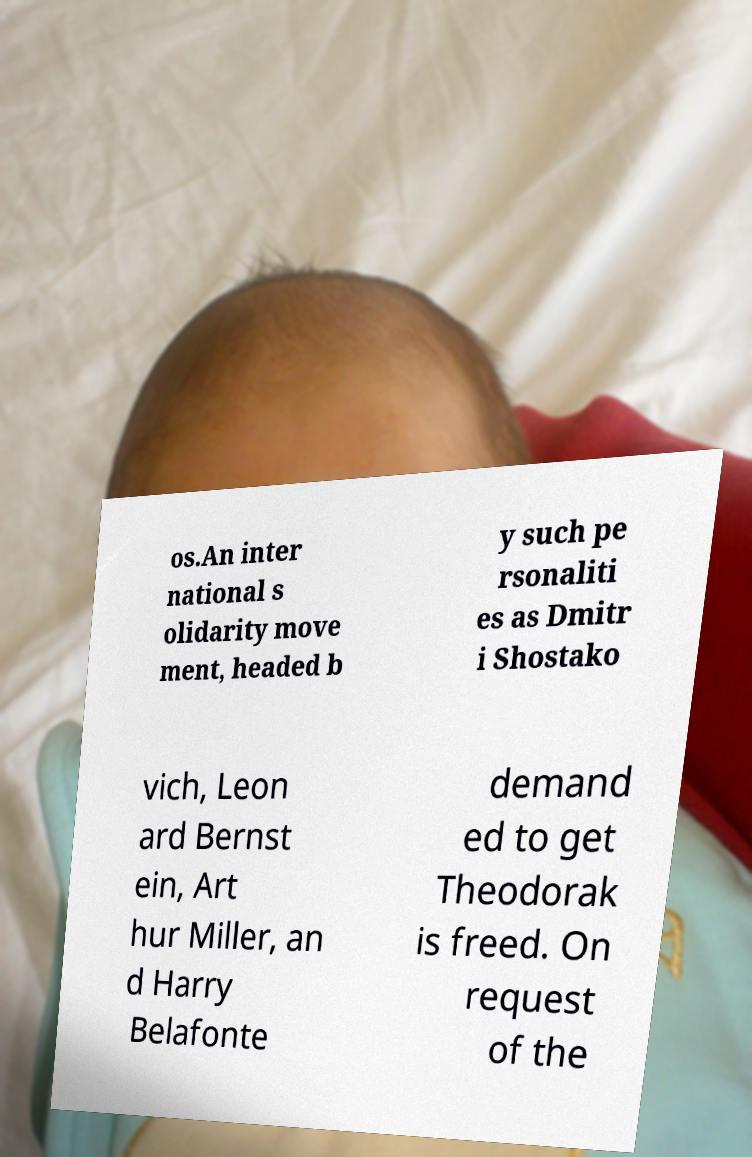What messages or text are displayed in this image? I need them in a readable, typed format. os.An inter national s olidarity move ment, headed b y such pe rsonaliti es as Dmitr i Shostako vich, Leon ard Bernst ein, Art hur Miller, an d Harry Belafonte demand ed to get Theodorak is freed. On request of the 